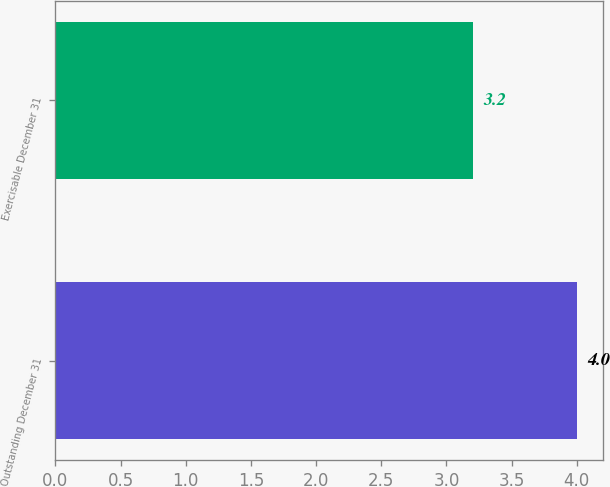Convert chart. <chart><loc_0><loc_0><loc_500><loc_500><bar_chart><fcel>Outstanding December 31<fcel>Exercisable December 31<nl><fcel>4<fcel>3.2<nl></chart> 